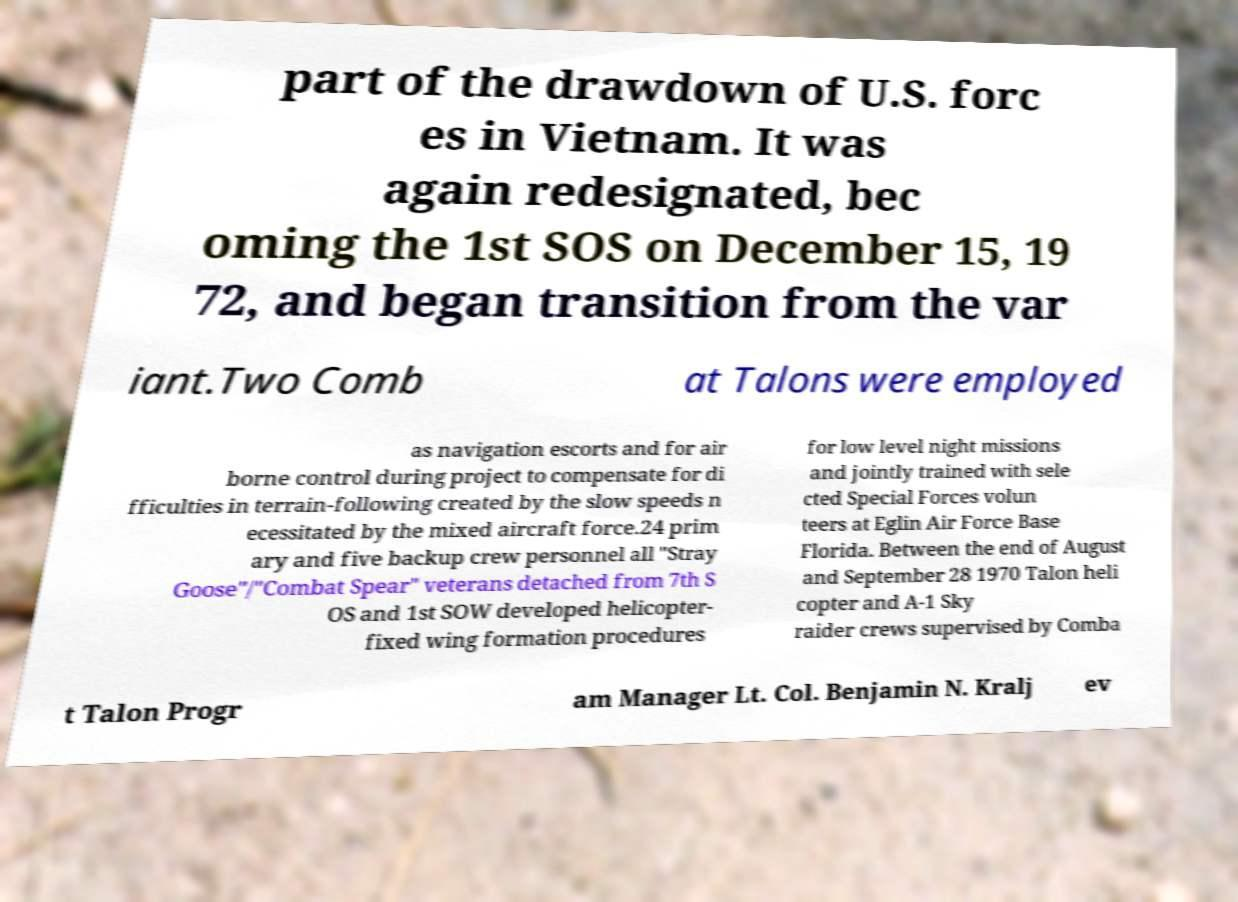Can you accurately transcribe the text from the provided image for me? part of the drawdown of U.S. forc es in Vietnam. It was again redesignated, bec oming the 1st SOS on December 15, 19 72, and began transition from the var iant.Two Comb at Talons were employed as navigation escorts and for air borne control during project to compensate for di fficulties in terrain-following created by the slow speeds n ecessitated by the mixed aircraft force.24 prim ary and five backup crew personnel all "Stray Goose"/"Combat Spear" veterans detached from 7th S OS and 1st SOW developed helicopter- fixed wing formation procedures for low level night missions and jointly trained with sele cted Special Forces volun teers at Eglin Air Force Base Florida. Between the end of August and September 28 1970 Talon heli copter and A-1 Sky raider crews supervised by Comba t Talon Progr am Manager Lt. Col. Benjamin N. Kralj ev 